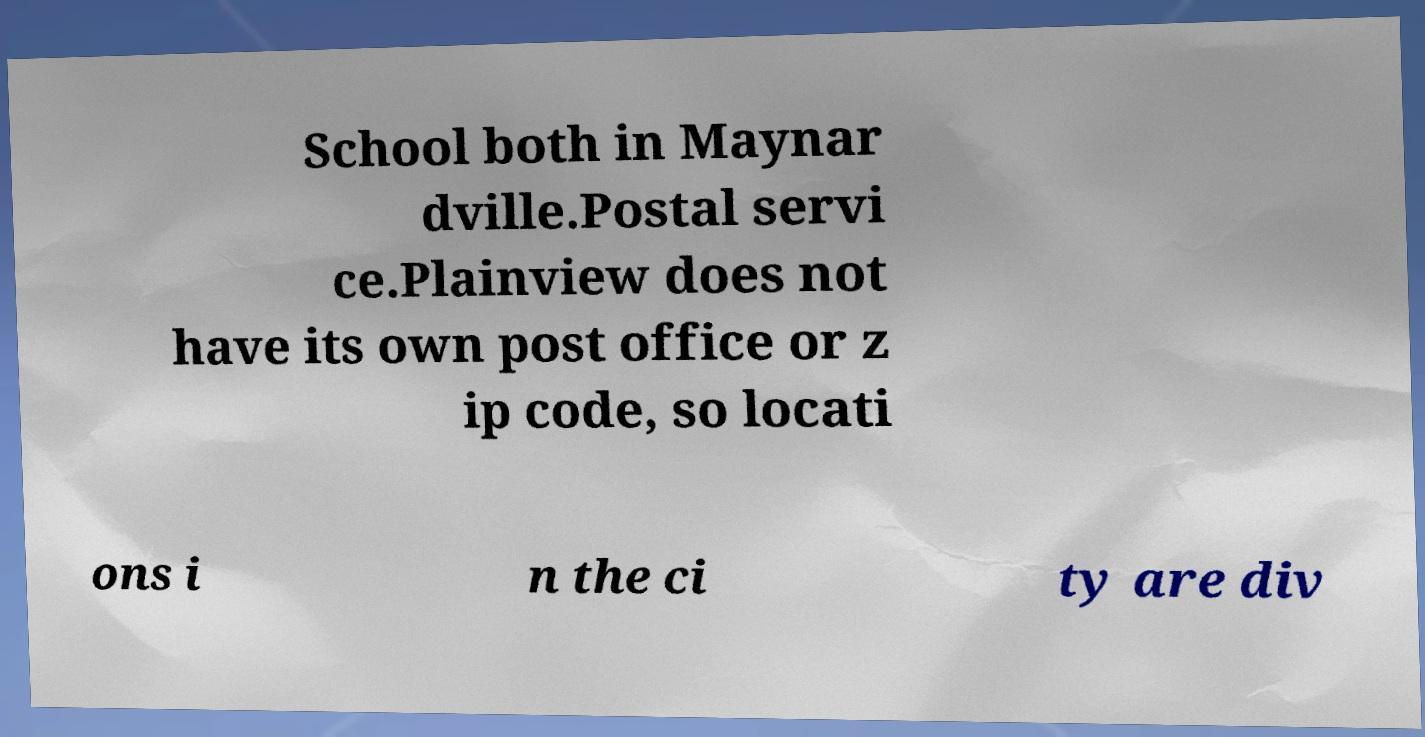There's text embedded in this image that I need extracted. Can you transcribe it verbatim? School both in Maynar dville.Postal servi ce.Plainview does not have its own post office or z ip code, so locati ons i n the ci ty are div 